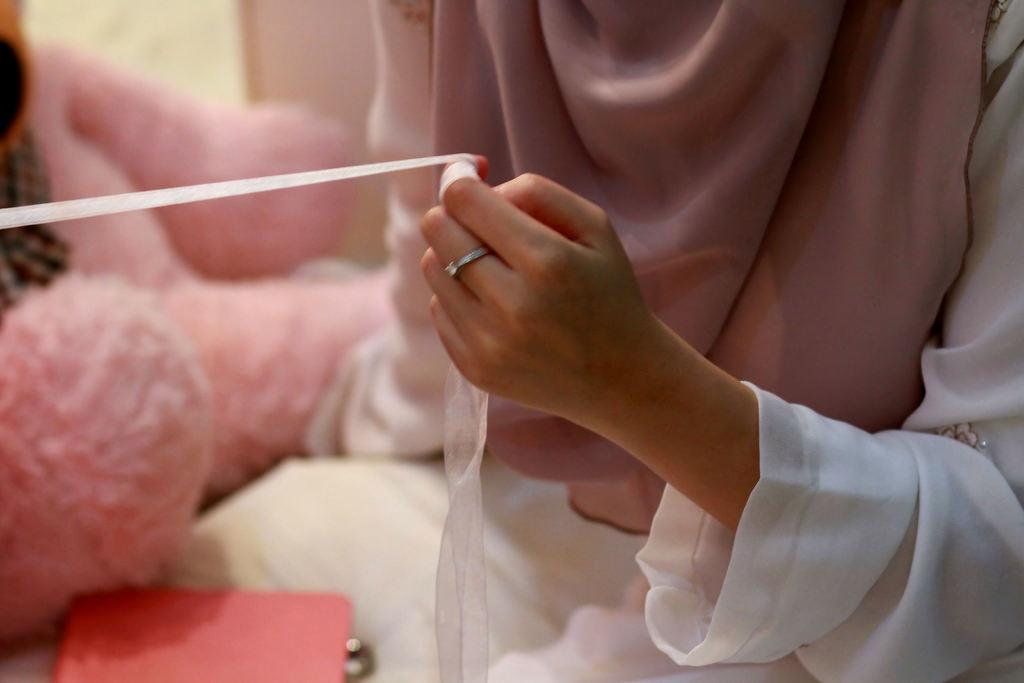What is the main subject of the image? There is a person in the image. What is the person holding in the image? The person is holding a paper plaster. What other object can be seen in the image? There is a teddy bear on the left side of the image. How many planes are visible in the image? There are no planes visible in the image. What type of rose can be seen in the image? There is no rose present in the image. 